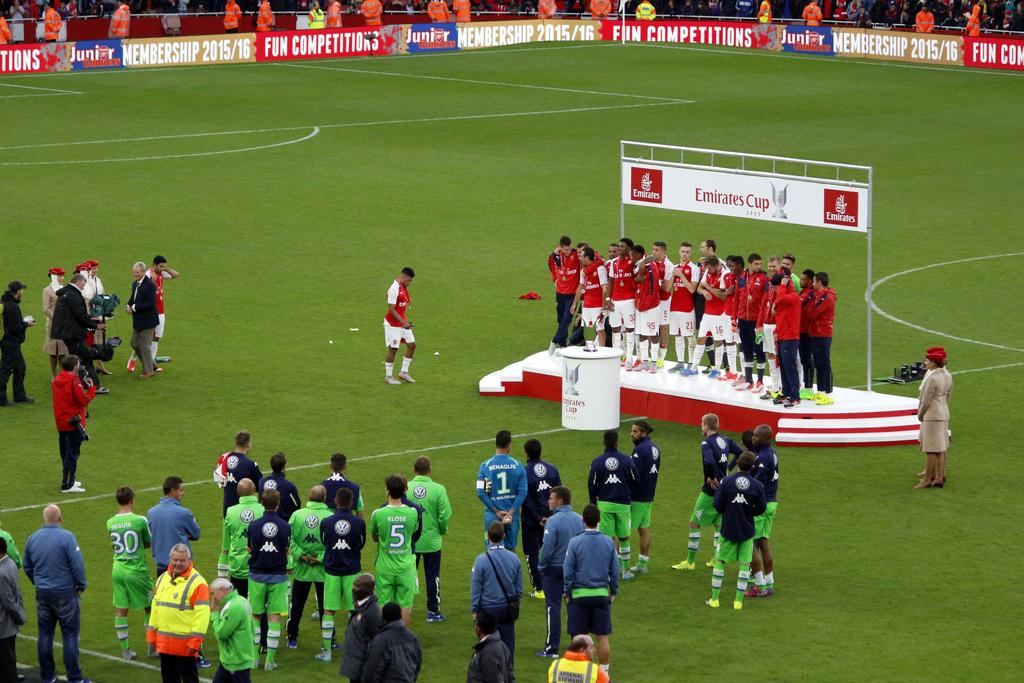<image>
Give a short and clear explanation of the subsequent image. soccer players on a Emirates cup stage sign 